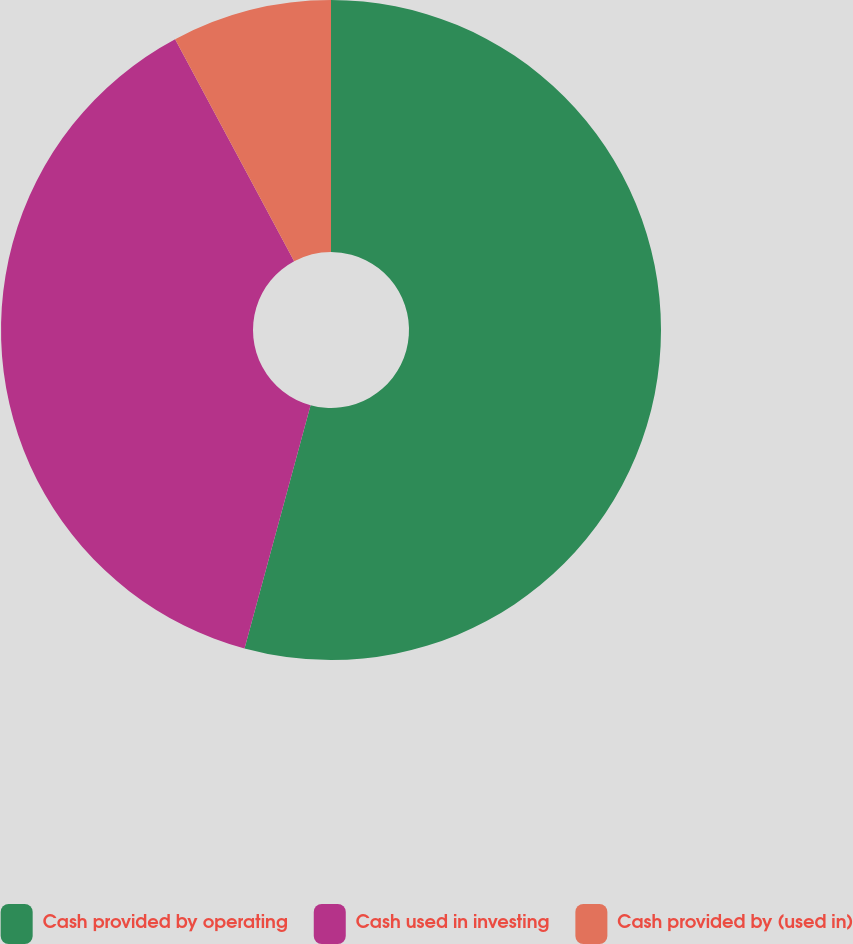Convert chart. <chart><loc_0><loc_0><loc_500><loc_500><pie_chart><fcel>Cash provided by operating<fcel>Cash used in investing<fcel>Cash provided by (used in)<nl><fcel>54.22%<fcel>37.95%<fcel>7.83%<nl></chart> 